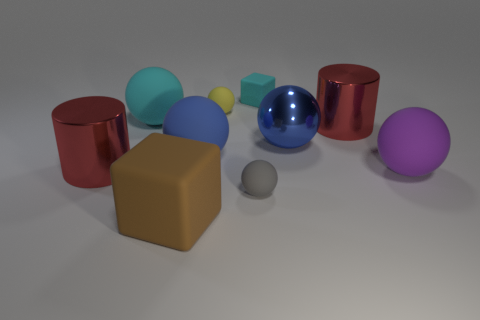What color is the big metallic cylinder that is to the left of the big blue metallic ball behind the tiny ball in front of the purple object?
Provide a succinct answer. Red. What shape is the red metal object that is in front of the big red thing that is to the right of the brown cube?
Offer a very short reply. Cylinder. Are there more blue rubber objects that are on the right side of the large brown matte block than tiny matte blocks?
Offer a terse response. No. Is the shape of the red metal thing on the left side of the cyan cube the same as  the yellow thing?
Your answer should be compact. No. Is there a large blue metal thing of the same shape as the tiny yellow matte thing?
Keep it short and to the point. Yes. What number of things are either red objects to the left of the large cyan matte object or cubes?
Ensure brevity in your answer.  3. Is the number of gray objects greater than the number of big rubber spheres?
Your answer should be very brief. No. Is there a blue cube of the same size as the cyan sphere?
Offer a terse response. No. How many things are small rubber objects that are left of the tiny cyan thing or big rubber balls behind the big purple ball?
Make the answer very short. 4. What is the color of the cylinder behind the large blue rubber object that is behind the big purple rubber sphere?
Provide a succinct answer. Red. 